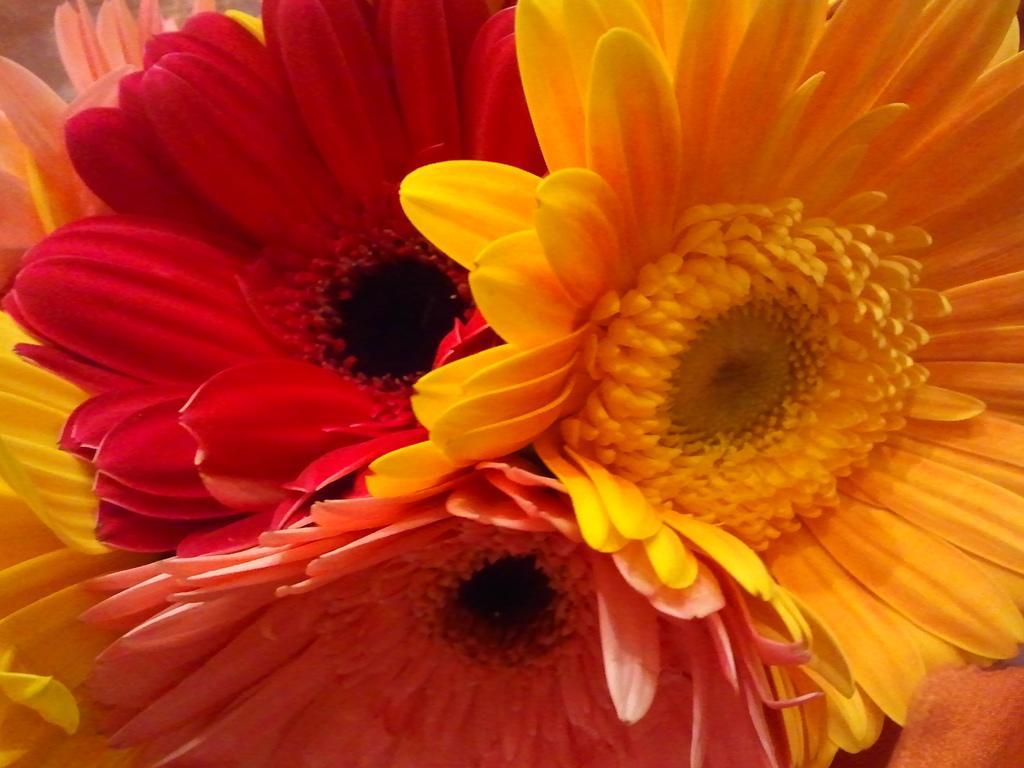In one or two sentences, can you explain what this image depicts? In the image we can see some flowers. 